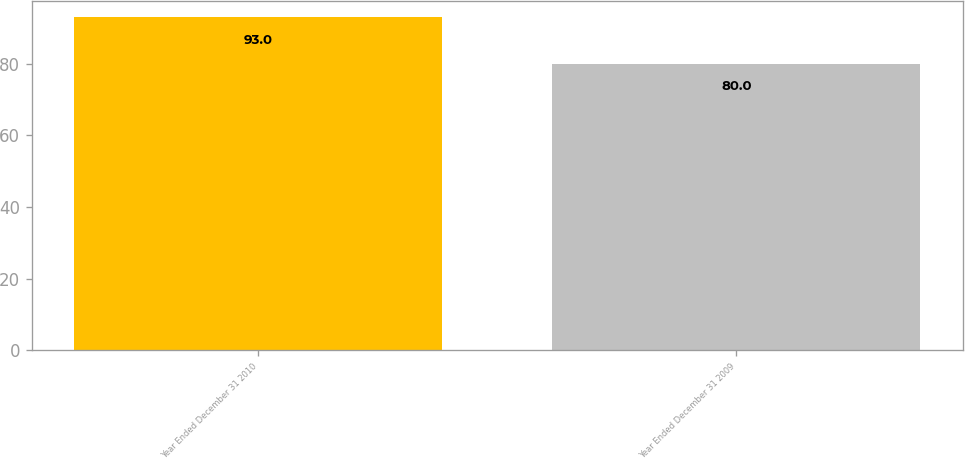Convert chart to OTSL. <chart><loc_0><loc_0><loc_500><loc_500><bar_chart><fcel>Year Ended December 31 2010<fcel>Year Ended December 31 2009<nl><fcel>93<fcel>80<nl></chart> 